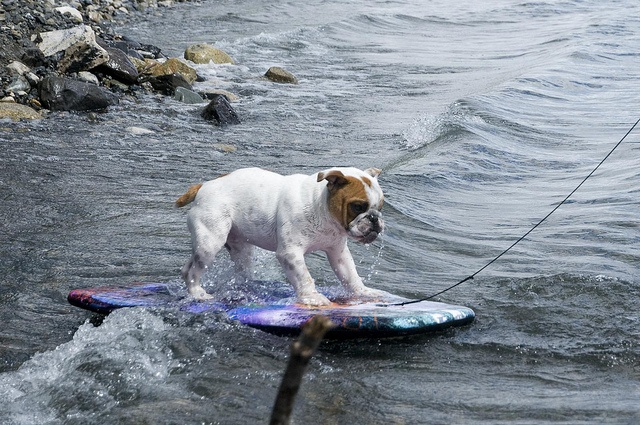Describe the objects in this image and their specific colors. I can see dog in gray, lightgray, and darkgray tones and surfboard in gray, black, and darkgray tones in this image. 